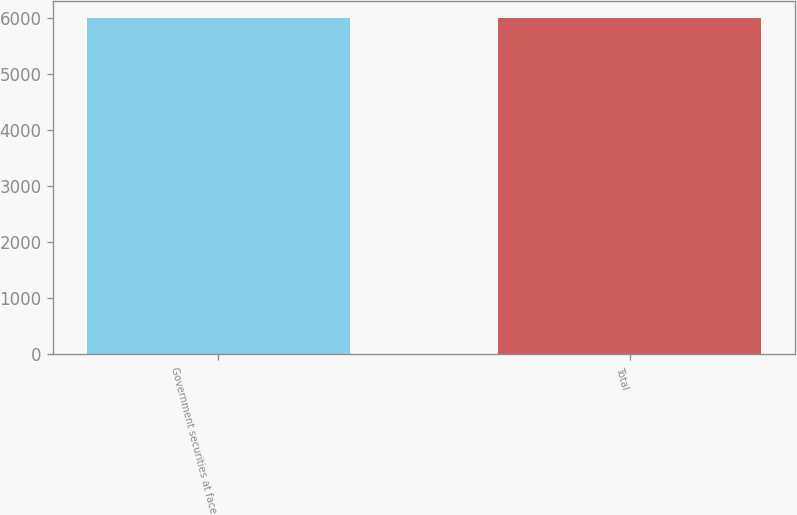Convert chart. <chart><loc_0><loc_0><loc_500><loc_500><bar_chart><fcel>Government securities at face<fcel>Total<nl><fcel>6013<fcel>6013.1<nl></chart> 